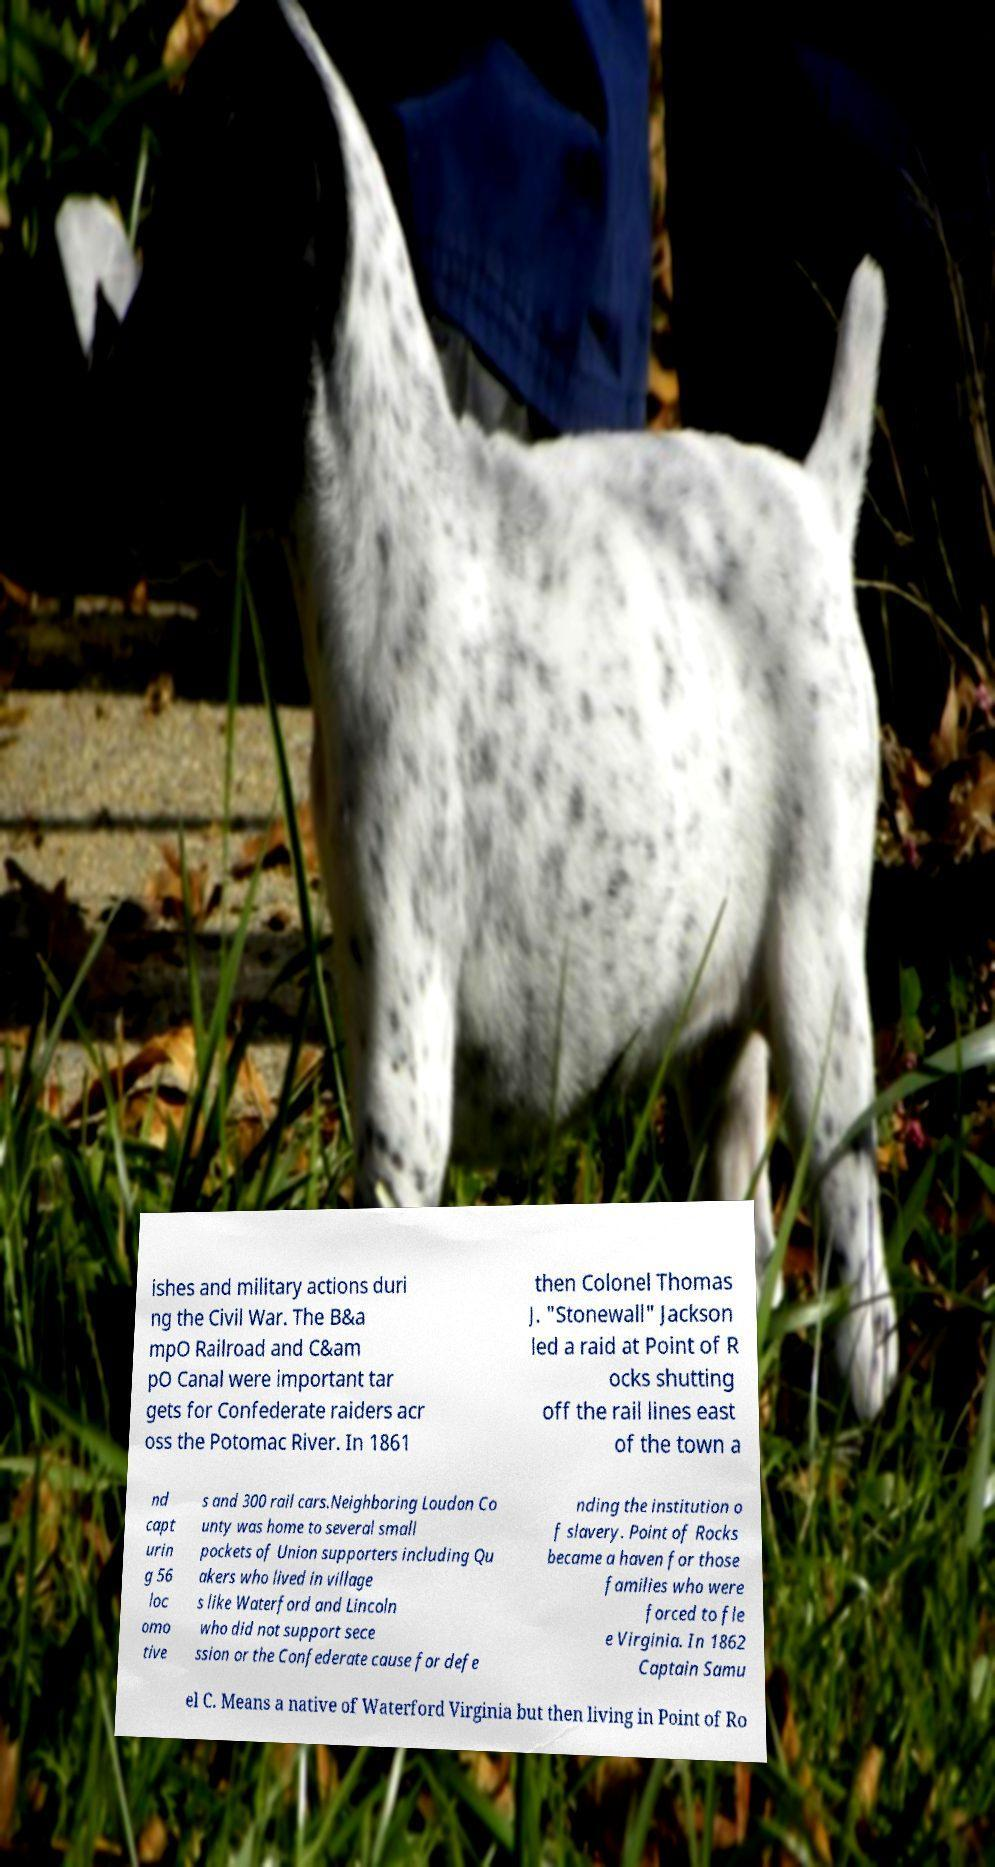What messages or text are displayed in this image? I need them in a readable, typed format. ishes and military actions duri ng the Civil War. The B&a mpO Railroad and C&am pO Canal were important tar gets for Confederate raiders acr oss the Potomac River. In 1861 then Colonel Thomas J. "Stonewall" Jackson led a raid at Point of R ocks shutting off the rail lines east of the town a nd capt urin g 56 loc omo tive s and 300 rail cars.Neighboring Loudon Co unty was home to several small pockets of Union supporters including Qu akers who lived in village s like Waterford and Lincoln who did not support sece ssion or the Confederate cause for defe nding the institution o f slavery. Point of Rocks became a haven for those families who were forced to fle e Virginia. In 1862 Captain Samu el C. Means a native of Waterford Virginia but then living in Point of Ro 